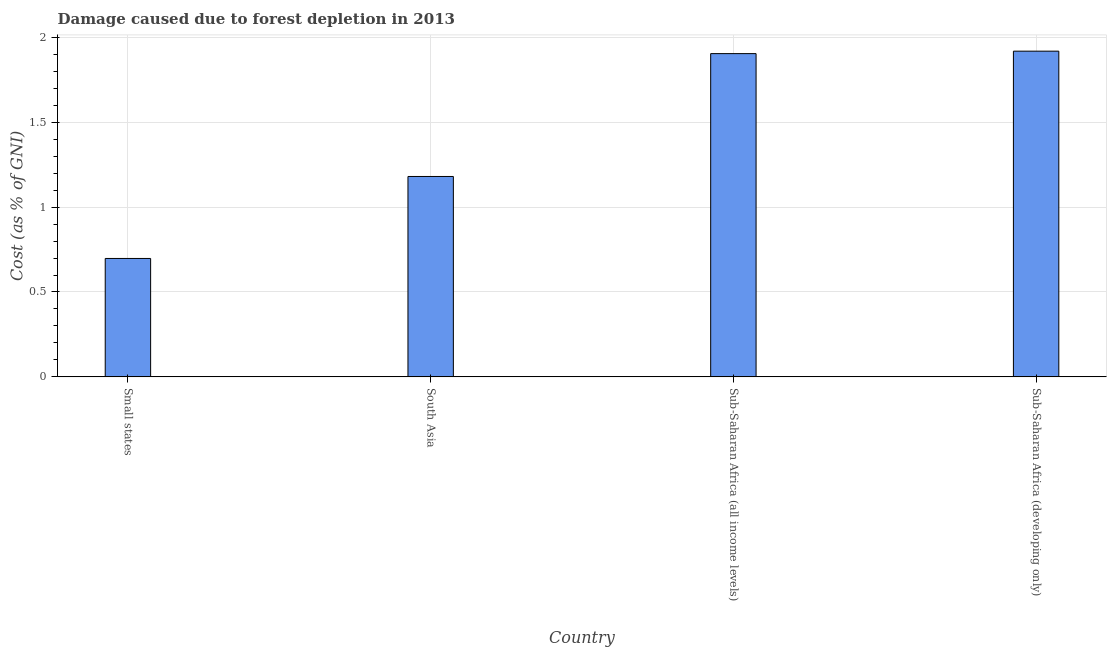Does the graph contain grids?
Your answer should be compact. Yes. What is the title of the graph?
Provide a succinct answer. Damage caused due to forest depletion in 2013. What is the label or title of the X-axis?
Your response must be concise. Country. What is the label or title of the Y-axis?
Offer a terse response. Cost (as % of GNI). What is the damage caused due to forest depletion in Sub-Saharan Africa (developing only)?
Ensure brevity in your answer.  1.92. Across all countries, what is the maximum damage caused due to forest depletion?
Ensure brevity in your answer.  1.92. Across all countries, what is the minimum damage caused due to forest depletion?
Make the answer very short. 0.7. In which country was the damage caused due to forest depletion maximum?
Offer a very short reply. Sub-Saharan Africa (developing only). In which country was the damage caused due to forest depletion minimum?
Ensure brevity in your answer.  Small states. What is the sum of the damage caused due to forest depletion?
Offer a terse response. 5.7. What is the difference between the damage caused due to forest depletion in Small states and Sub-Saharan Africa (developing only)?
Your response must be concise. -1.22. What is the average damage caused due to forest depletion per country?
Keep it short and to the point. 1.43. What is the median damage caused due to forest depletion?
Your response must be concise. 1.54. In how many countries, is the damage caused due to forest depletion greater than 0.5 %?
Your response must be concise. 4. What is the ratio of the damage caused due to forest depletion in Small states to that in Sub-Saharan Africa (developing only)?
Your answer should be compact. 0.36. What is the difference between the highest and the second highest damage caused due to forest depletion?
Your answer should be compact. 0.01. What is the difference between the highest and the lowest damage caused due to forest depletion?
Offer a very short reply. 1.22. In how many countries, is the damage caused due to forest depletion greater than the average damage caused due to forest depletion taken over all countries?
Provide a succinct answer. 2. How many bars are there?
Provide a short and direct response. 4. Are all the bars in the graph horizontal?
Keep it short and to the point. No. What is the difference between two consecutive major ticks on the Y-axis?
Your answer should be compact. 0.5. Are the values on the major ticks of Y-axis written in scientific E-notation?
Make the answer very short. No. What is the Cost (as % of GNI) of Small states?
Keep it short and to the point. 0.7. What is the Cost (as % of GNI) in South Asia?
Offer a very short reply. 1.18. What is the Cost (as % of GNI) of Sub-Saharan Africa (all income levels)?
Offer a terse response. 1.9. What is the Cost (as % of GNI) in Sub-Saharan Africa (developing only)?
Offer a very short reply. 1.92. What is the difference between the Cost (as % of GNI) in Small states and South Asia?
Your response must be concise. -0.48. What is the difference between the Cost (as % of GNI) in Small states and Sub-Saharan Africa (all income levels)?
Offer a very short reply. -1.21. What is the difference between the Cost (as % of GNI) in Small states and Sub-Saharan Africa (developing only)?
Give a very brief answer. -1.22. What is the difference between the Cost (as % of GNI) in South Asia and Sub-Saharan Africa (all income levels)?
Your response must be concise. -0.72. What is the difference between the Cost (as % of GNI) in South Asia and Sub-Saharan Africa (developing only)?
Offer a very short reply. -0.74. What is the difference between the Cost (as % of GNI) in Sub-Saharan Africa (all income levels) and Sub-Saharan Africa (developing only)?
Your response must be concise. -0.01. What is the ratio of the Cost (as % of GNI) in Small states to that in South Asia?
Your answer should be compact. 0.59. What is the ratio of the Cost (as % of GNI) in Small states to that in Sub-Saharan Africa (all income levels)?
Offer a very short reply. 0.37. What is the ratio of the Cost (as % of GNI) in Small states to that in Sub-Saharan Africa (developing only)?
Provide a short and direct response. 0.36. What is the ratio of the Cost (as % of GNI) in South Asia to that in Sub-Saharan Africa (all income levels)?
Give a very brief answer. 0.62. What is the ratio of the Cost (as % of GNI) in South Asia to that in Sub-Saharan Africa (developing only)?
Your answer should be very brief. 0.61. What is the ratio of the Cost (as % of GNI) in Sub-Saharan Africa (all income levels) to that in Sub-Saharan Africa (developing only)?
Offer a very short reply. 0.99. 